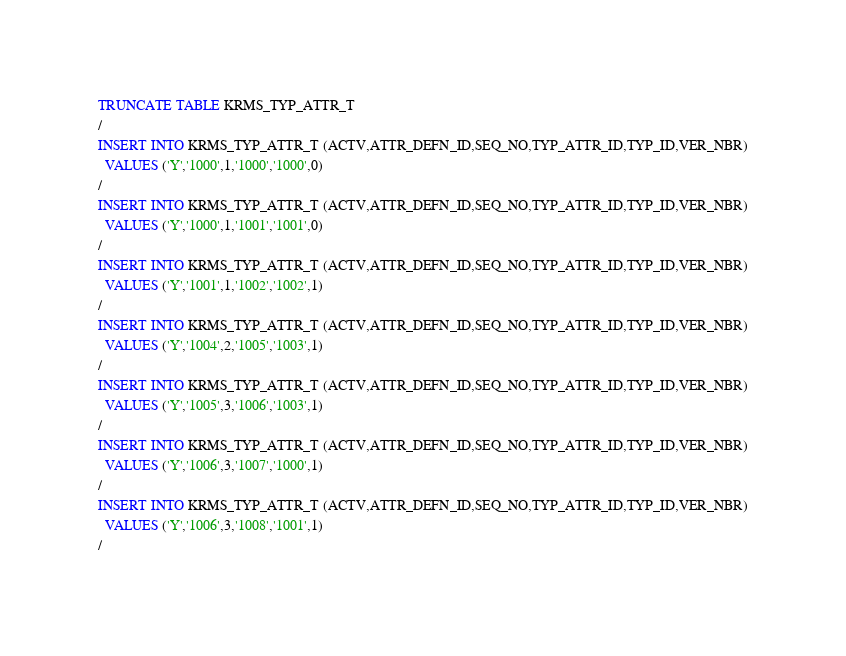Convert code to text. <code><loc_0><loc_0><loc_500><loc_500><_SQL_>TRUNCATE TABLE KRMS_TYP_ATTR_T
/
INSERT INTO KRMS_TYP_ATTR_T (ACTV,ATTR_DEFN_ID,SEQ_NO,TYP_ATTR_ID,TYP_ID,VER_NBR)
  VALUES ('Y','1000',1,'1000','1000',0)
/
INSERT INTO KRMS_TYP_ATTR_T (ACTV,ATTR_DEFN_ID,SEQ_NO,TYP_ATTR_ID,TYP_ID,VER_NBR)
  VALUES ('Y','1000',1,'1001','1001',0)
/
INSERT INTO KRMS_TYP_ATTR_T (ACTV,ATTR_DEFN_ID,SEQ_NO,TYP_ATTR_ID,TYP_ID,VER_NBR)
  VALUES ('Y','1001',1,'1002','1002',1)
/
INSERT INTO KRMS_TYP_ATTR_T (ACTV,ATTR_DEFN_ID,SEQ_NO,TYP_ATTR_ID,TYP_ID,VER_NBR)
  VALUES ('Y','1004',2,'1005','1003',1)
/
INSERT INTO KRMS_TYP_ATTR_T (ACTV,ATTR_DEFN_ID,SEQ_NO,TYP_ATTR_ID,TYP_ID,VER_NBR)
  VALUES ('Y','1005',3,'1006','1003',1)
/
INSERT INTO KRMS_TYP_ATTR_T (ACTV,ATTR_DEFN_ID,SEQ_NO,TYP_ATTR_ID,TYP_ID,VER_NBR)
  VALUES ('Y','1006',3,'1007','1000',1)
/
INSERT INTO KRMS_TYP_ATTR_T (ACTV,ATTR_DEFN_ID,SEQ_NO,TYP_ATTR_ID,TYP_ID,VER_NBR)
  VALUES ('Y','1006',3,'1008','1001',1)
/
</code> 